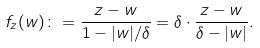Convert formula to latex. <formula><loc_0><loc_0><loc_500><loc_500>f _ { z } ( w ) \colon = \frac { z - w } { 1 - | w | / \delta } = \delta \cdot \frac { z - w } { \delta - | w | } .</formula> 